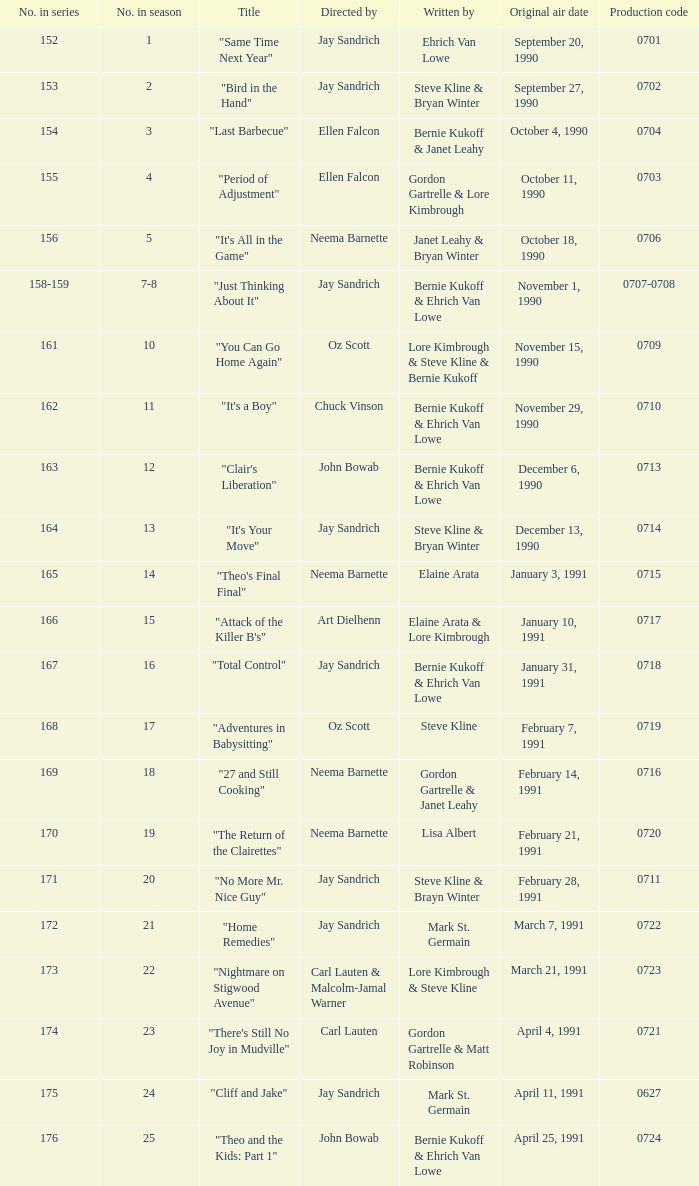Who directed the episode entitled "it's your move"? Jay Sandrich. 